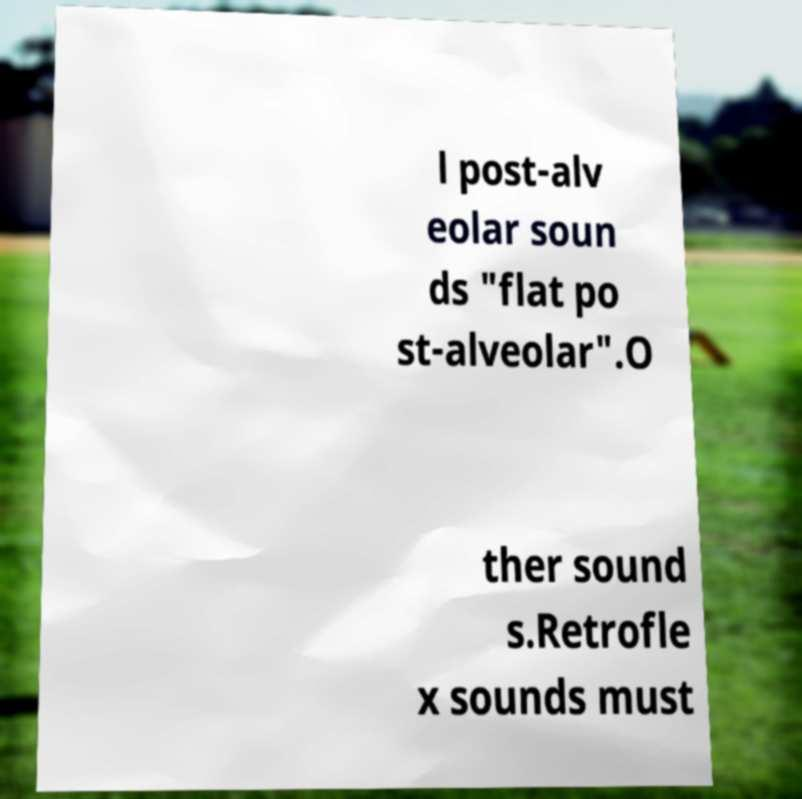What messages or text are displayed in this image? I need them in a readable, typed format. l post-alv eolar soun ds "flat po st-alveolar".O ther sound s.Retrofle x sounds must 